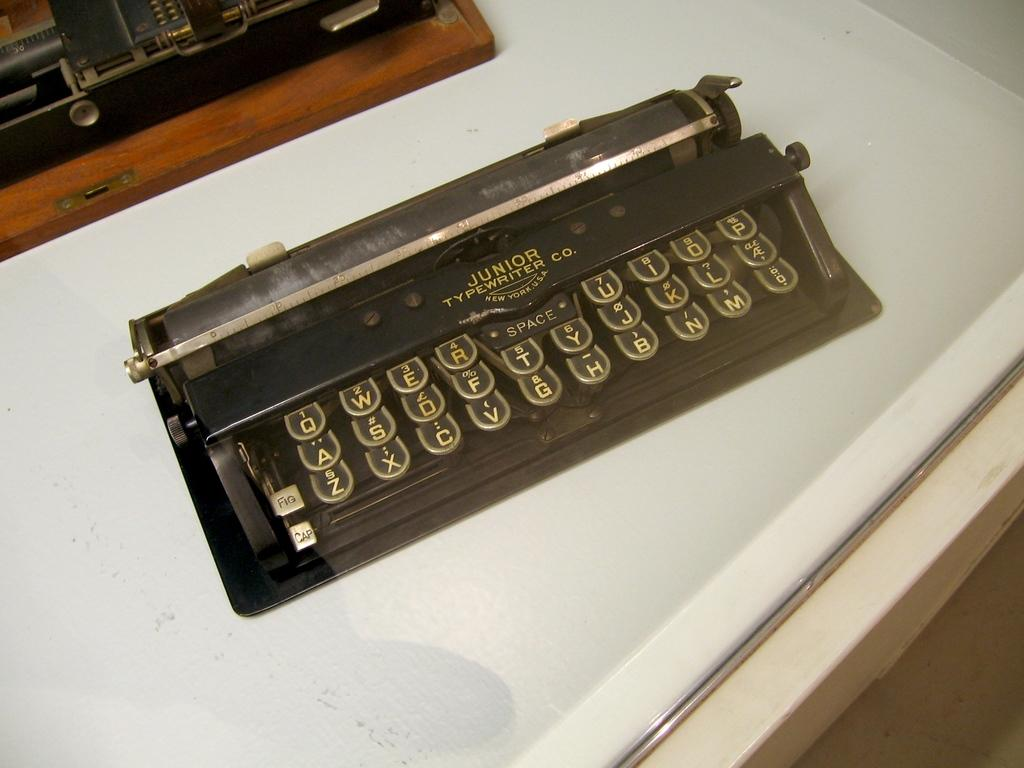<image>
Render a clear and concise summary of the photo. a junior brand typewriten in black with gold letters 